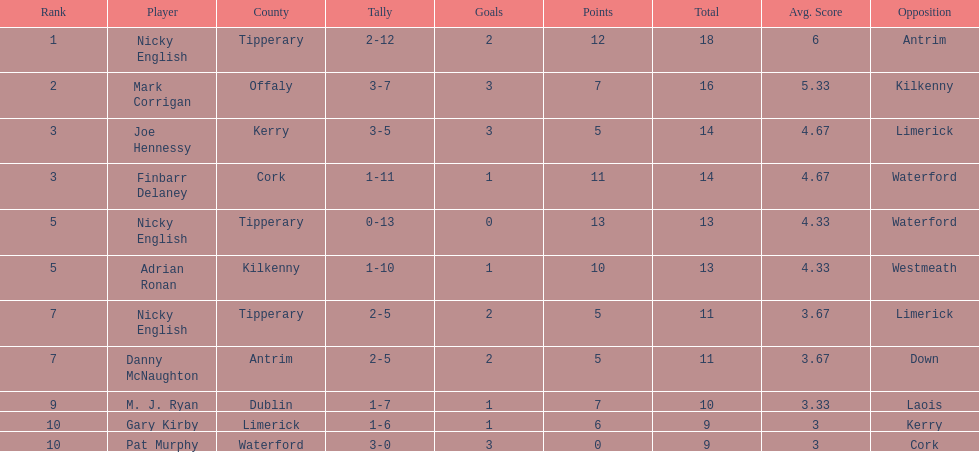Which player ranked the most? Nicky English. 